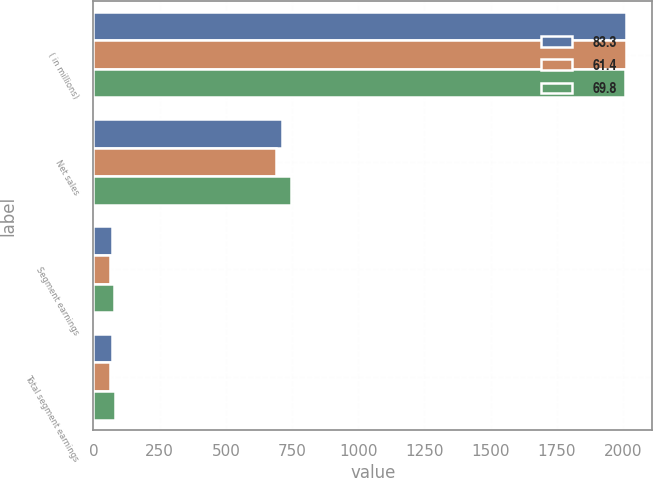Convert chart. <chart><loc_0><loc_0><loc_500><loc_500><stacked_bar_chart><ecel><fcel>( in millions)<fcel>Net sales<fcel>Segment earnings<fcel>Total segment earnings<nl><fcel>83.3<fcel>2010<fcel>713.7<fcel>69.8<fcel>69.8<nl><fcel>61.4<fcel>2009<fcel>689.2<fcel>61.4<fcel>61.4<nl><fcel>69.8<fcel>2008<fcel>746.5<fcel>76.2<fcel>83.3<nl></chart> 